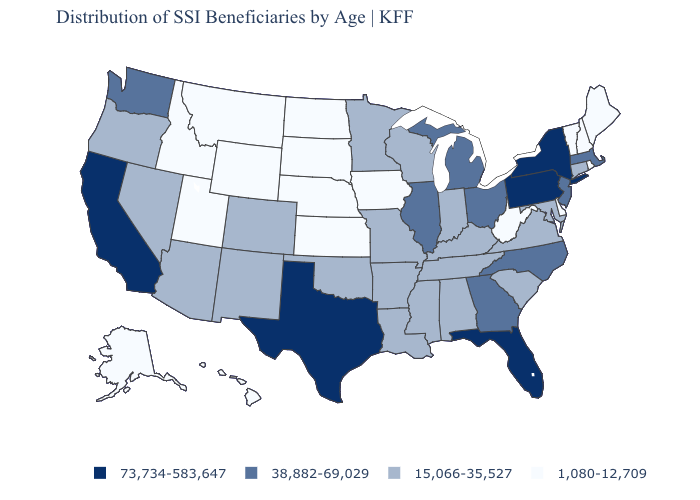Name the states that have a value in the range 38,882-69,029?
Concise answer only. Georgia, Illinois, Massachusetts, Michigan, New Jersey, North Carolina, Ohio, Washington. Does the map have missing data?
Concise answer only. No. What is the value of Oregon?
Keep it brief. 15,066-35,527. Name the states that have a value in the range 1,080-12,709?
Be succinct. Alaska, Delaware, Hawaii, Idaho, Iowa, Kansas, Maine, Montana, Nebraska, New Hampshire, North Dakota, Rhode Island, South Dakota, Utah, Vermont, West Virginia, Wyoming. Does Wyoming have the same value as Iowa?
Concise answer only. Yes. Does the first symbol in the legend represent the smallest category?
Keep it brief. No. Does South Dakota have a lower value than Louisiana?
Short answer required. Yes. What is the value of Massachusetts?
Write a very short answer. 38,882-69,029. What is the value of Indiana?
Be succinct. 15,066-35,527. Does New York have the lowest value in the Northeast?
Quick response, please. No. Does Maryland have a lower value than Texas?
Keep it brief. Yes. Which states have the lowest value in the USA?
Give a very brief answer. Alaska, Delaware, Hawaii, Idaho, Iowa, Kansas, Maine, Montana, Nebraska, New Hampshire, North Dakota, Rhode Island, South Dakota, Utah, Vermont, West Virginia, Wyoming. Among the states that border Nebraska , which have the lowest value?
Answer briefly. Iowa, Kansas, South Dakota, Wyoming. How many symbols are there in the legend?
Concise answer only. 4. Is the legend a continuous bar?
Be succinct. No. 